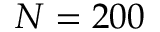<formula> <loc_0><loc_0><loc_500><loc_500>N = 2 0 0</formula> 